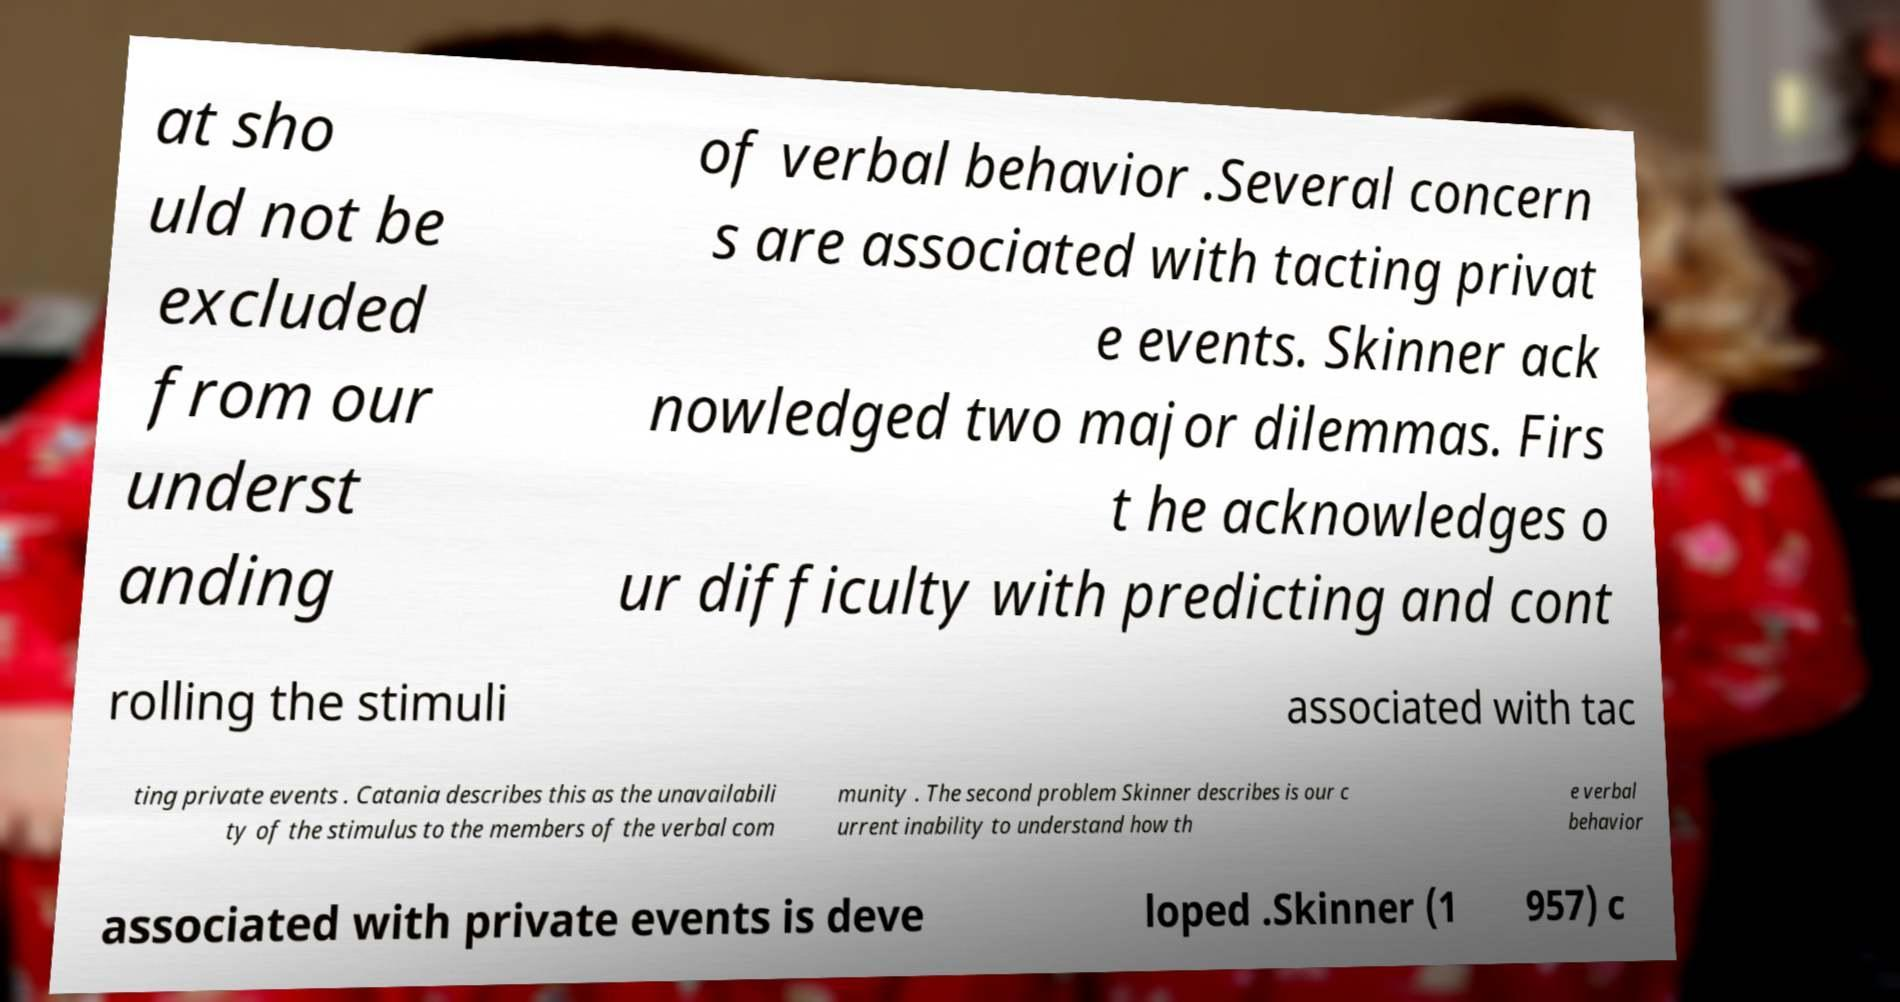Please identify and transcribe the text found in this image. at sho uld not be excluded from our underst anding of verbal behavior .Several concern s are associated with tacting privat e events. Skinner ack nowledged two major dilemmas. Firs t he acknowledges o ur difficulty with predicting and cont rolling the stimuli associated with tac ting private events . Catania describes this as the unavailabili ty of the stimulus to the members of the verbal com munity . The second problem Skinner describes is our c urrent inability to understand how th e verbal behavior associated with private events is deve loped .Skinner (1 957) c 